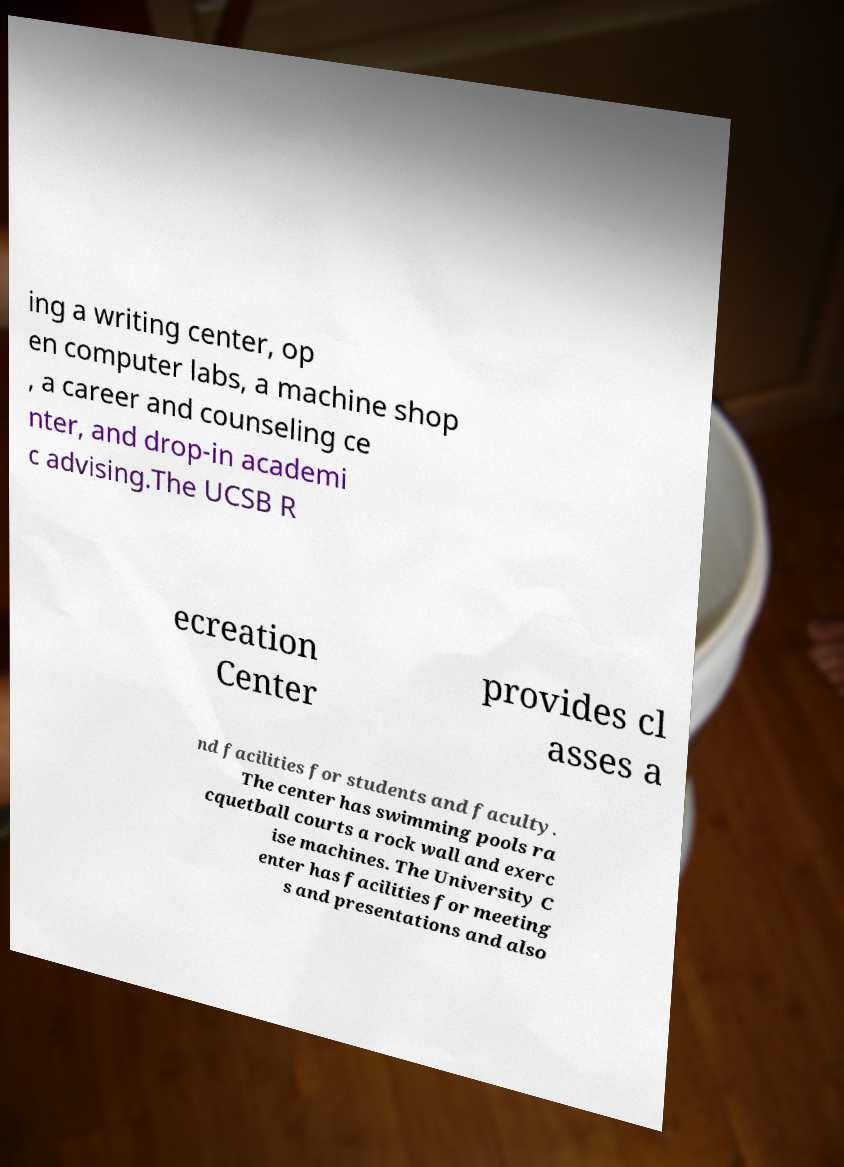Please identify and transcribe the text found in this image. ing a writing center, op en computer labs, a machine shop , a career and counseling ce nter, and drop-in academi c advising.The UCSB R ecreation Center provides cl asses a nd facilities for students and faculty. The center has swimming pools ra cquetball courts a rock wall and exerc ise machines. The University C enter has facilities for meeting s and presentations and also 